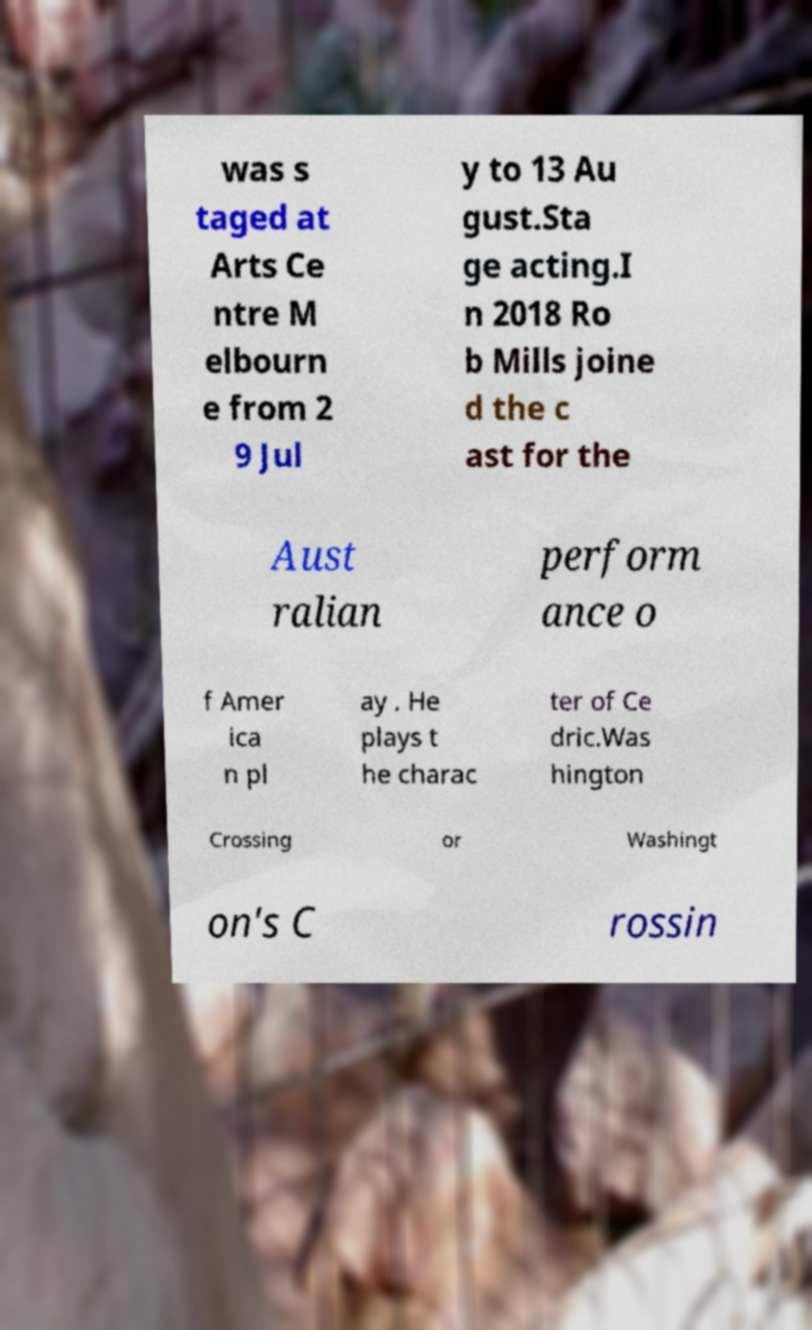Can you read and provide the text displayed in the image?This photo seems to have some interesting text. Can you extract and type it out for me? was s taged at Arts Ce ntre M elbourn e from 2 9 Jul y to 13 Au gust.Sta ge acting.I n 2018 Ro b Mills joine d the c ast for the Aust ralian perform ance o f Amer ica n pl ay . He plays t he charac ter of Ce dric.Was hington Crossing or Washingt on's C rossin 